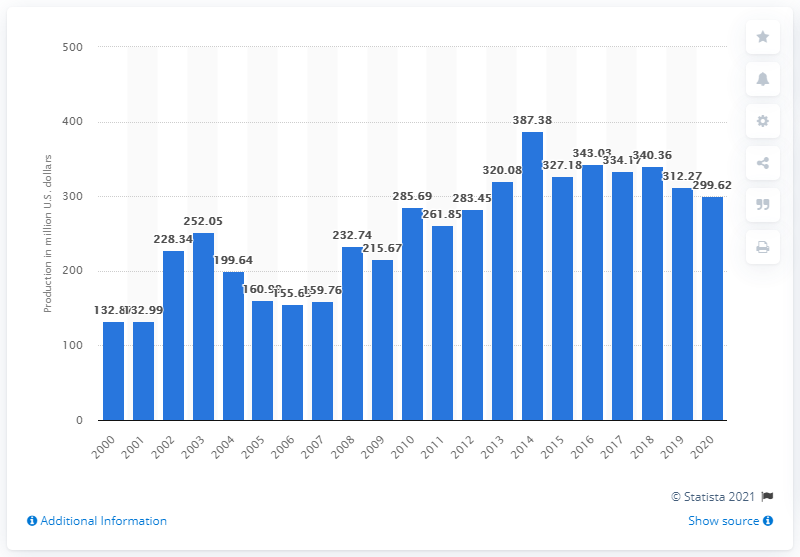Give some essential details in this illustration. In 2020, the value of honey production in the United States was 299.62 million dollars. 